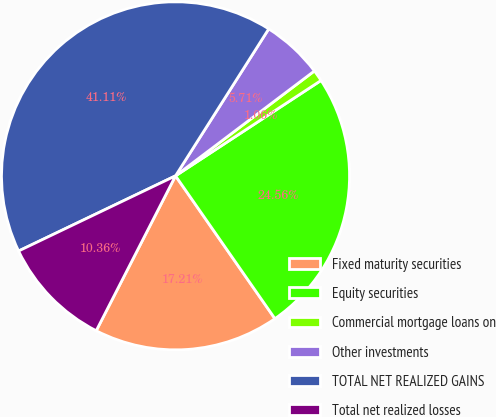<chart> <loc_0><loc_0><loc_500><loc_500><pie_chart><fcel>Fixed maturity securities<fcel>Equity securities<fcel>Commercial mortgage loans on<fcel>Other investments<fcel>TOTAL NET REALIZED GAINS<fcel>Total net realized losses<nl><fcel>17.21%<fcel>24.56%<fcel>1.06%<fcel>5.71%<fcel>41.11%<fcel>10.36%<nl></chart> 